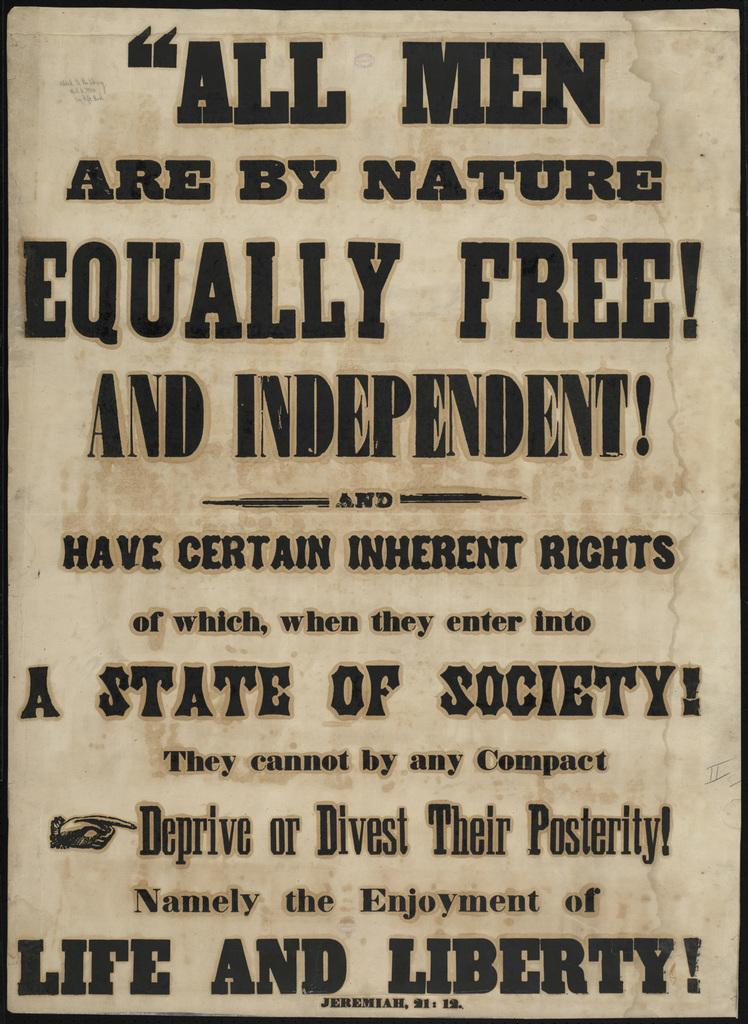<image>
Write a terse but informative summary of the picture. a poster that says 'life and liberty!' at the bottom 